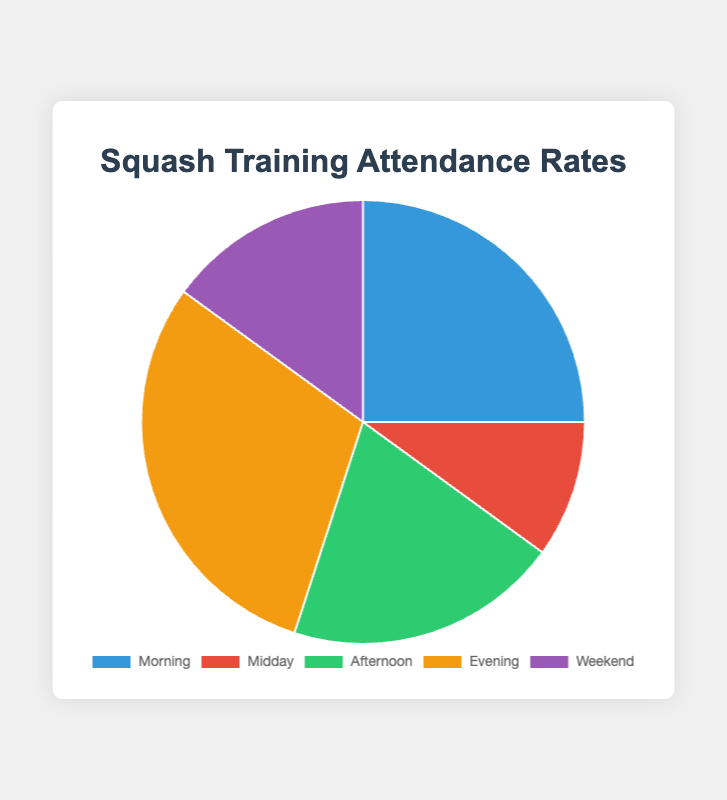What is the percentage of attendance for the Evening session? The figure shows the Evening session with a specific color segment labeled with its percentage. By identifying the Evening segment, you see it is 30%.
Answer: 30% Which session has the lowest attendance percentage? The figure displays percentage values for each session type. By comparing them, the Midday session has the lowest value at 10%.
Answer: Midday Sum of attendance percentages for Morning and Weekend sessions Locate the Morning and Weekend segments in the chart, and sum their percentages: 25% (Morning) + 15% (Weekend) = 40%.
Answer: 40% Which session has a higher attendance, Afternoon or Weekend, and by how much? Identify the percentages for Afternoon (20%) and Weekend (15%). Calculate the difference: 20% - 15% = 5%. Afternoon has a higher attendance by 5%.
Answer: Afternoon by 5% What is the total percentage of attendance for sessions other than Evening? First, find the Evening percentage (30%). Then, sum the percentages of all other sessions: 25% (Morning) + 10% (Midday) + 20% (Afternoon) + 15% (Weekend) = 70%.
Answer: 70% Which color represents the Midday session in the pie chart? The chart uses visually distinct colors for each session. The Midday session is shown in the second color along the legend. The description provided indicates this color is red.
Answer: Red Calculate the average attendance percentage across all sessions. Calculate the sum of all session percentages: 25% (Morning) + 10% (Midday) + 20% (Afternoon) + 30% (Evening) + 15% (Weekend) = 100%. Then, divide by the number of sessions (5): 100% / 5 = 20%.
Answer: 20% Which sessions have a higher attendance rate than 20%? Compare each session's percentage against 20%. The Morning (25%) and Evening (30%) sessions both exceed 20%.
Answer: Morning and Evening What percentage of total attendance is accounted for by the three most popular sessions? Identify the top three sessions by attendance: Evening (30%), Morning (25%), and Afternoon (20%). Sum these percentages: 30% + 25% + 20% = 75%.
Answer: 75% What is the difference in attendance percentage between the session with the highest and lowest attendance? Find the highest (Evening, 30%) and lowest (Midday, 10%) percentages. Calculate the difference: 30% - 10% = 20%.
Answer: 20% 